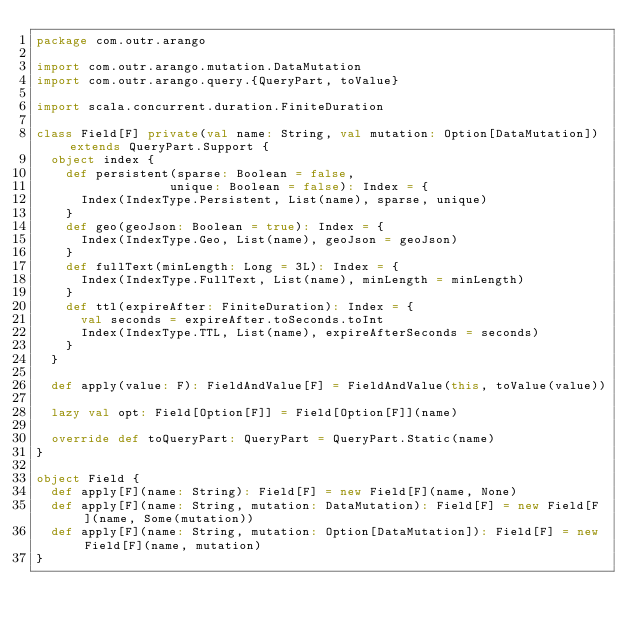Convert code to text. <code><loc_0><loc_0><loc_500><loc_500><_Scala_>package com.outr.arango

import com.outr.arango.mutation.DataMutation
import com.outr.arango.query.{QueryPart, toValue}

import scala.concurrent.duration.FiniteDuration

class Field[F] private(val name: String, val mutation: Option[DataMutation]) extends QueryPart.Support {
  object index {
    def persistent(sparse: Boolean = false,
                  unique: Boolean = false): Index = {
      Index(IndexType.Persistent, List(name), sparse, unique)
    }
    def geo(geoJson: Boolean = true): Index = {
      Index(IndexType.Geo, List(name), geoJson = geoJson)
    }
    def fullText(minLength: Long = 3L): Index = {
      Index(IndexType.FullText, List(name), minLength = minLength)
    }
    def ttl(expireAfter: FiniteDuration): Index = {
      val seconds = expireAfter.toSeconds.toInt
      Index(IndexType.TTL, List(name), expireAfterSeconds = seconds)
    }
  }

  def apply(value: F): FieldAndValue[F] = FieldAndValue(this, toValue(value))

  lazy val opt: Field[Option[F]] = Field[Option[F]](name)

  override def toQueryPart: QueryPart = QueryPart.Static(name)
}

object Field {
  def apply[F](name: String): Field[F] = new Field[F](name, None)
  def apply[F](name: String, mutation: DataMutation): Field[F] = new Field[F](name, Some(mutation))
  def apply[F](name: String, mutation: Option[DataMutation]): Field[F] = new Field[F](name, mutation)
}</code> 